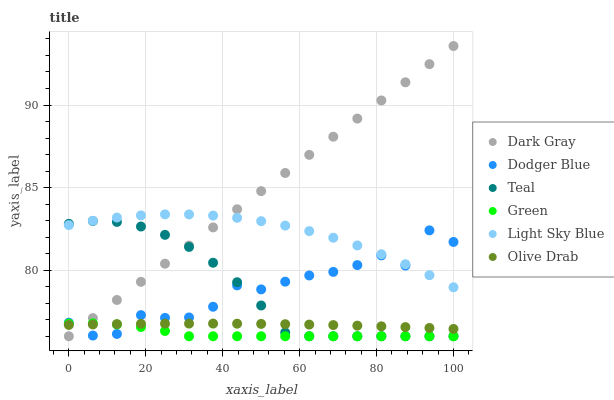Does Green have the minimum area under the curve?
Answer yes or no. Yes. Does Dark Gray have the maximum area under the curve?
Answer yes or no. Yes. Does Light Sky Blue have the minimum area under the curve?
Answer yes or no. No. Does Light Sky Blue have the maximum area under the curve?
Answer yes or no. No. Is Dark Gray the smoothest?
Answer yes or no. Yes. Is Dodger Blue the roughest?
Answer yes or no. Yes. Is Light Sky Blue the smoothest?
Answer yes or no. No. Is Light Sky Blue the roughest?
Answer yes or no. No. Does Dark Gray have the lowest value?
Answer yes or no. Yes. Does Light Sky Blue have the lowest value?
Answer yes or no. No. Does Dark Gray have the highest value?
Answer yes or no. Yes. Does Light Sky Blue have the highest value?
Answer yes or no. No. Is Green less than Light Sky Blue?
Answer yes or no. Yes. Is Light Sky Blue greater than Green?
Answer yes or no. Yes. Does Dark Gray intersect Teal?
Answer yes or no. Yes. Is Dark Gray less than Teal?
Answer yes or no. No. Is Dark Gray greater than Teal?
Answer yes or no. No. Does Green intersect Light Sky Blue?
Answer yes or no. No. 